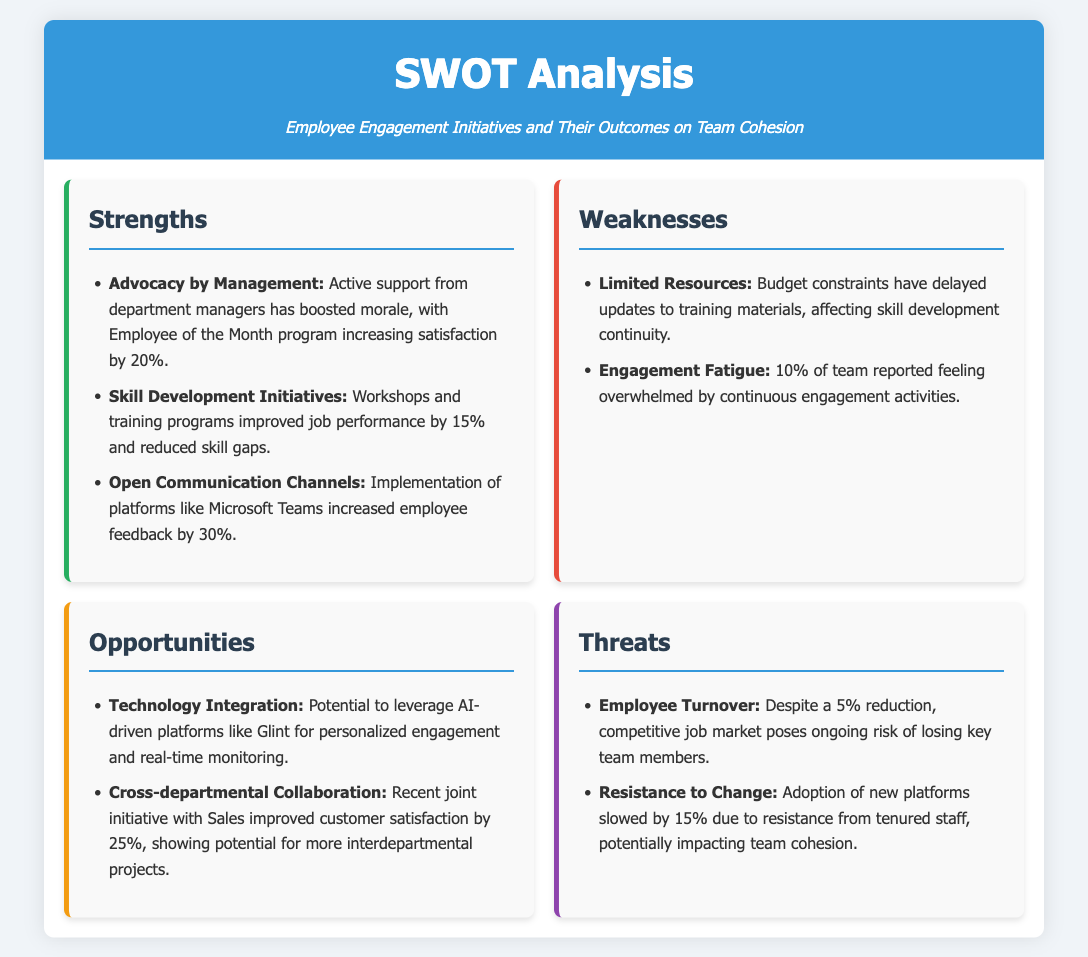What increased employee satisfaction by 20%? The document notes that the Employee of the Month program has boosted morale and increased satisfaction by 20%.
Answer: Employee of the Month program What percentage did skill development initiatives improve job performance? Skill development initiatives improved job performance by stating a specific improvement percentage in the document.
Answer: 15% What platform increased employee feedback by 30%? The implementation of Microsoft Teams is mentioned as a platform that enhanced employee feedback.
Answer: Microsoft Teams What is one weakness related to employee engagement activities? The document specifically identifies engagement fatigue as a weakness affecting some employees.
Answer: Engagement Fatigue What is a potential technology opportunity mentioned in the document? The document presents AI-driven platforms like Glint as a technology opportunity for personalized engagement.
Answer: AI-driven platforms like Glint What is the percentage reduction in employee turnover reported? The document mentions a 5% reduction in employee turnover, highlighting an improvement.
Answer: 5% What factor is slowing the adoption of new platforms by staff? Resistance from tenured staff is explicitly stated as a factor that is hindering the adoption of new platforms.
Answer: Resistance to Change What type of initiatives improved customer satisfaction by 25%? The document references a joint initiative with Sales as having contributed to improved customer satisfaction.
Answer: Joint initiative with Sales 